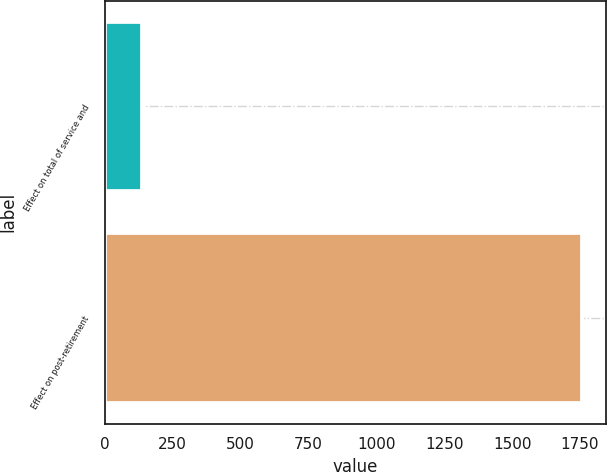Convert chart. <chart><loc_0><loc_0><loc_500><loc_500><bar_chart><fcel>Effect on total of service and<fcel>Effect on post-retirement<nl><fcel>139<fcel>1756<nl></chart> 